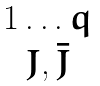Convert formula to latex. <formula><loc_0><loc_0><loc_500><loc_500>\begin{matrix} 1 \dots q \\ J , \bar { J } \end{matrix}</formula> 